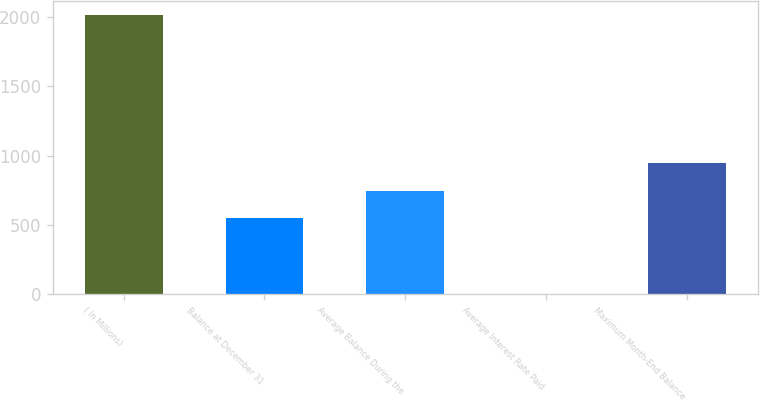Convert chart to OTSL. <chart><loc_0><loc_0><loc_500><loc_500><bar_chart><fcel>( In Millions)<fcel>Balance at December 31<fcel>Average Balance During the<fcel>Average Interest Rate Paid<fcel>Maximum Month-End Balance<nl><fcel>2015<fcel>546.6<fcel>748.1<fcel>0.05<fcel>949.6<nl></chart> 